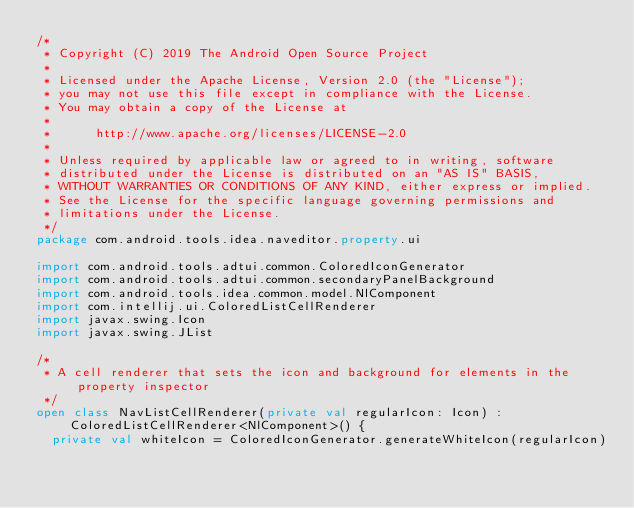<code> <loc_0><loc_0><loc_500><loc_500><_Kotlin_>/*
 * Copyright (C) 2019 The Android Open Source Project
 *
 * Licensed under the Apache License, Version 2.0 (the "License");
 * you may not use this file except in compliance with the License.
 * You may obtain a copy of the License at
 *
 *      http://www.apache.org/licenses/LICENSE-2.0
 *
 * Unless required by applicable law or agreed to in writing, software
 * distributed under the License is distributed on an "AS IS" BASIS,
 * WITHOUT WARRANTIES OR CONDITIONS OF ANY KIND, either express or implied.
 * See the License for the specific language governing permissions and
 * limitations under the License.
 */
package com.android.tools.idea.naveditor.property.ui

import com.android.tools.adtui.common.ColoredIconGenerator
import com.android.tools.adtui.common.secondaryPanelBackground
import com.android.tools.idea.common.model.NlComponent
import com.intellij.ui.ColoredListCellRenderer
import javax.swing.Icon
import javax.swing.JList

/*
 * A cell renderer that sets the icon and background for elements in the property inspector
 */
open class NavListCellRenderer(private val regularIcon: Icon) : ColoredListCellRenderer<NlComponent>() {
  private val whiteIcon = ColoredIconGenerator.generateWhiteIcon(regularIcon)
</code> 